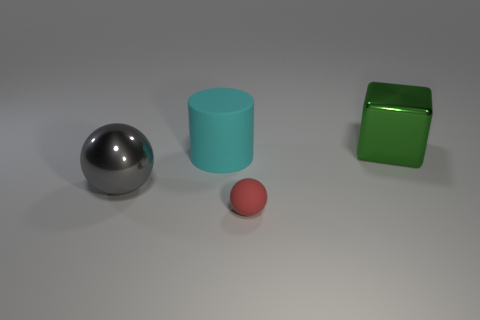Add 2 large green cubes. How many objects exist? 6 Subtract all cylinders. How many objects are left? 3 Subtract all large objects. Subtract all tiny brown matte cylinders. How many objects are left? 1 Add 4 large cylinders. How many large cylinders are left? 5 Add 3 purple objects. How many purple objects exist? 3 Subtract 0 brown balls. How many objects are left? 4 